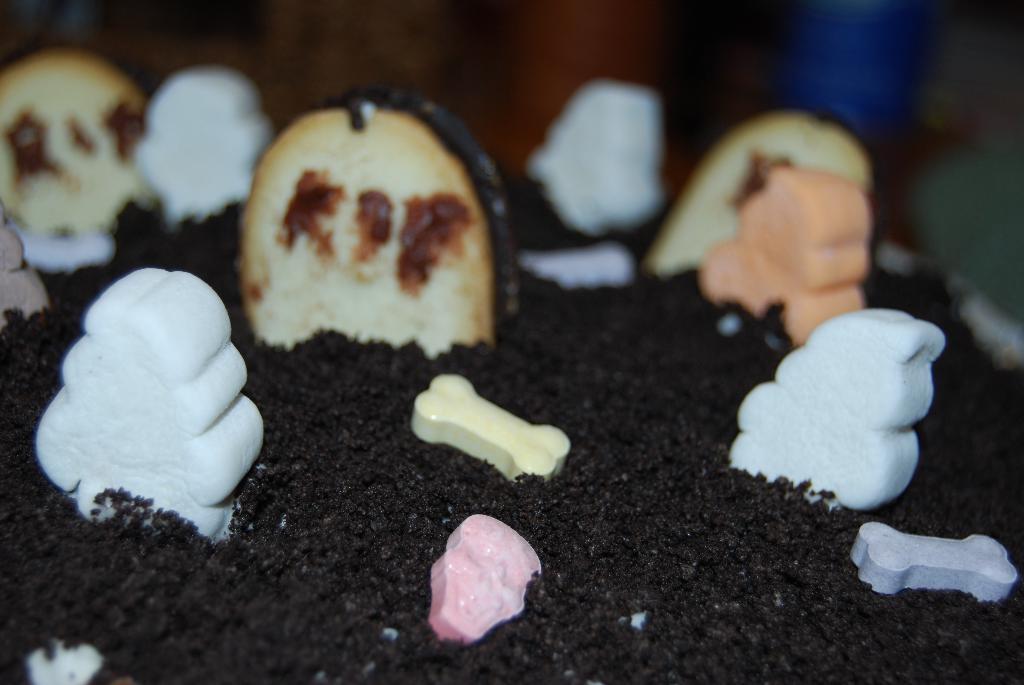How would you summarize this image in a sentence or two? In the image we can see a cake and the background is blurred. 